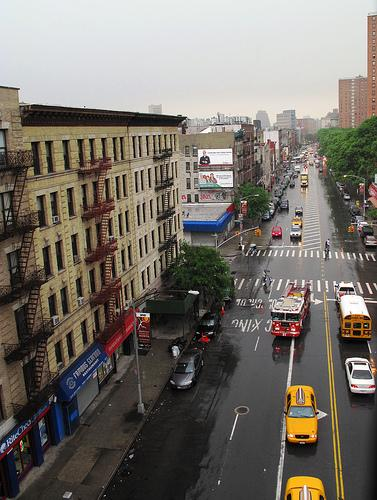Identify the primary mode of transportation seen in the image. Yellow taxi cabs are the main mode of transportation in the picture. Describe the scene, summarizing the objects in the image that are most likely to grab attention. On a rainy day, yellow taxi cabs, a fire truck, and an assortment of cars share the city street, with billboards overhead and buildings featuring black fire escapes on the side. If you were to advertise a product in this image, what elements could you highlight? For a car tire advertisement, one could emphasize the wet road conditions, the variety of vehicles present, and the tarmac road setting. Describe the characteristics of the trees and where they are located in relation to the image.  Row of green bushy trees are present, located above the vehicles, adding a natural touch amidst the urban setting. Choose the correct statement: A) There are two school buses in the image; B) There is one fire truck in the image; C) There are five yellow cabs in the image. B) There is one fire truck in the image. What action is happening with the traffic light and how does it affect the vehicles? The traffic light is on red, causing vehicles to come to a stop or wait at the intersection. Determine the main architectural feature on the side of one of the buildings and its color. Black fire escapes on the side of the building are the main architectural feature. Mention the types of vehicles present in the scene and their colors. There are yellow taxi cabs, a red fire truck, a white car, a gray car, and a yellow and white school bus in the scene. In a poetic style, describe the environment surrounding the buildings in the image. Amidst the bustling city street, green bushy trees stand tall and proud, offering a serene escape as the rain-washed streets reflect the day. Imagine you need to guide someone to locate the fire truck. How would you describe its position?  Look for the red fire truck on the left side of the school bus and the street light pole, amidst other vehicles on the wet road. 